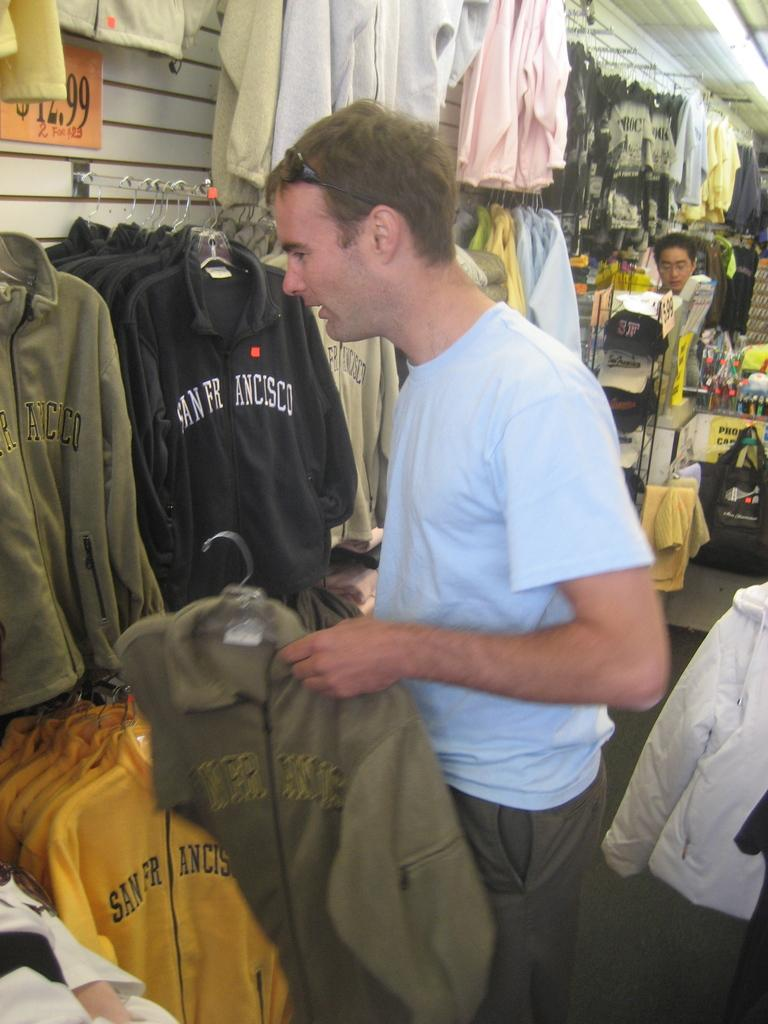<image>
Relay a brief, clear account of the picture shown. A man in a clothing store next to sweatshirts with San Francisco written on them 